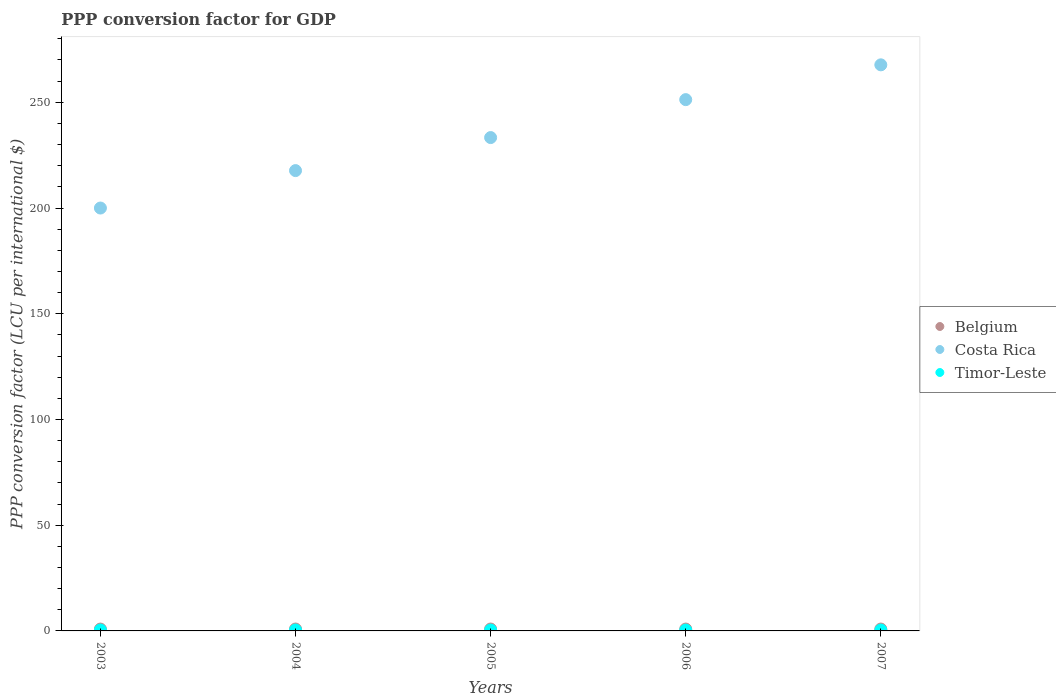How many different coloured dotlines are there?
Ensure brevity in your answer.  3. Is the number of dotlines equal to the number of legend labels?
Provide a short and direct response. Yes. What is the PPP conversion factor for GDP in Costa Rica in 2005?
Your response must be concise. 233.31. Across all years, what is the maximum PPP conversion factor for GDP in Belgium?
Offer a very short reply. 0.9. Across all years, what is the minimum PPP conversion factor for GDP in Belgium?
Keep it short and to the point. 0.88. In which year was the PPP conversion factor for GDP in Timor-Leste maximum?
Offer a terse response. 2003. In which year was the PPP conversion factor for GDP in Timor-Leste minimum?
Your response must be concise. 2006. What is the total PPP conversion factor for GDP in Costa Rica in the graph?
Your answer should be compact. 1169.97. What is the difference between the PPP conversion factor for GDP in Belgium in 2003 and that in 2007?
Offer a very short reply. -0.01. What is the difference between the PPP conversion factor for GDP in Costa Rica in 2003 and the PPP conversion factor for GDP in Timor-Leste in 2005?
Provide a succinct answer. 199.58. What is the average PPP conversion factor for GDP in Timor-Leste per year?
Your answer should be very brief. 0.41. In the year 2006, what is the difference between the PPP conversion factor for GDP in Costa Rica and PPP conversion factor for GDP in Belgium?
Ensure brevity in your answer.  250.38. In how many years, is the PPP conversion factor for GDP in Belgium greater than 50 LCU?
Provide a short and direct response. 0. What is the ratio of the PPP conversion factor for GDP in Costa Rica in 2003 to that in 2006?
Give a very brief answer. 0.8. Is the PPP conversion factor for GDP in Costa Rica in 2005 less than that in 2006?
Your answer should be compact. Yes. What is the difference between the highest and the second highest PPP conversion factor for GDP in Costa Rica?
Your answer should be very brief. 16.45. What is the difference between the highest and the lowest PPP conversion factor for GDP in Timor-Leste?
Your answer should be very brief. 0.03. Is it the case that in every year, the sum of the PPP conversion factor for GDP in Timor-Leste and PPP conversion factor for GDP in Belgium  is greater than the PPP conversion factor for GDP in Costa Rica?
Offer a terse response. No. Does the PPP conversion factor for GDP in Timor-Leste monotonically increase over the years?
Make the answer very short. No. Is the PPP conversion factor for GDP in Costa Rica strictly greater than the PPP conversion factor for GDP in Belgium over the years?
Make the answer very short. Yes. Is the PPP conversion factor for GDP in Costa Rica strictly less than the PPP conversion factor for GDP in Belgium over the years?
Keep it short and to the point. No. How many dotlines are there?
Make the answer very short. 3. How many years are there in the graph?
Your answer should be compact. 5. What is the difference between two consecutive major ticks on the Y-axis?
Make the answer very short. 50. How are the legend labels stacked?
Give a very brief answer. Vertical. What is the title of the graph?
Offer a very short reply. PPP conversion factor for GDP. Does "Guyana" appear as one of the legend labels in the graph?
Make the answer very short. No. What is the label or title of the X-axis?
Ensure brevity in your answer.  Years. What is the label or title of the Y-axis?
Provide a succinct answer. PPP conversion factor (LCU per international $). What is the PPP conversion factor (LCU per international $) of Belgium in 2003?
Offer a terse response. 0.88. What is the PPP conversion factor (LCU per international $) of Costa Rica in 2003?
Ensure brevity in your answer.  199.99. What is the PPP conversion factor (LCU per international $) of Timor-Leste in 2003?
Provide a short and direct response. 0.42. What is the PPP conversion factor (LCU per international $) of Belgium in 2004?
Provide a succinct answer. 0.9. What is the PPP conversion factor (LCU per international $) in Costa Rica in 2004?
Provide a short and direct response. 217.69. What is the PPP conversion factor (LCU per international $) of Timor-Leste in 2004?
Offer a very short reply. 0.42. What is the PPP conversion factor (LCU per international $) in Belgium in 2005?
Make the answer very short. 0.9. What is the PPP conversion factor (LCU per international $) in Costa Rica in 2005?
Make the answer very short. 233.31. What is the PPP conversion factor (LCU per international $) in Timor-Leste in 2005?
Offer a terse response. 0.41. What is the PPP conversion factor (LCU per international $) in Belgium in 2006?
Offer a very short reply. 0.88. What is the PPP conversion factor (LCU per international $) of Costa Rica in 2006?
Offer a very short reply. 251.26. What is the PPP conversion factor (LCU per international $) of Timor-Leste in 2006?
Offer a terse response. 0.39. What is the PPP conversion factor (LCU per international $) in Belgium in 2007?
Offer a very short reply. 0.89. What is the PPP conversion factor (LCU per international $) of Costa Rica in 2007?
Ensure brevity in your answer.  267.71. What is the PPP conversion factor (LCU per international $) in Timor-Leste in 2007?
Offer a very short reply. 0.42. Across all years, what is the maximum PPP conversion factor (LCU per international $) of Belgium?
Provide a short and direct response. 0.9. Across all years, what is the maximum PPP conversion factor (LCU per international $) of Costa Rica?
Keep it short and to the point. 267.71. Across all years, what is the maximum PPP conversion factor (LCU per international $) in Timor-Leste?
Ensure brevity in your answer.  0.42. Across all years, what is the minimum PPP conversion factor (LCU per international $) of Belgium?
Your answer should be very brief. 0.88. Across all years, what is the minimum PPP conversion factor (LCU per international $) in Costa Rica?
Ensure brevity in your answer.  199.99. Across all years, what is the minimum PPP conversion factor (LCU per international $) in Timor-Leste?
Your answer should be compact. 0.39. What is the total PPP conversion factor (LCU per international $) of Belgium in the graph?
Give a very brief answer. 4.44. What is the total PPP conversion factor (LCU per international $) in Costa Rica in the graph?
Provide a short and direct response. 1169.97. What is the total PPP conversion factor (LCU per international $) in Timor-Leste in the graph?
Make the answer very short. 2.07. What is the difference between the PPP conversion factor (LCU per international $) of Belgium in 2003 and that in 2004?
Make the answer very short. -0.02. What is the difference between the PPP conversion factor (LCU per international $) in Costa Rica in 2003 and that in 2004?
Your response must be concise. -17.7. What is the difference between the PPP conversion factor (LCU per international $) of Timor-Leste in 2003 and that in 2004?
Provide a succinct answer. 0. What is the difference between the PPP conversion factor (LCU per international $) of Belgium in 2003 and that in 2005?
Provide a short and direct response. -0.02. What is the difference between the PPP conversion factor (LCU per international $) in Costa Rica in 2003 and that in 2005?
Offer a very short reply. -33.32. What is the difference between the PPP conversion factor (LCU per international $) of Timor-Leste in 2003 and that in 2005?
Provide a succinct answer. 0.02. What is the difference between the PPP conversion factor (LCU per international $) in Belgium in 2003 and that in 2006?
Your answer should be compact. -0.01. What is the difference between the PPP conversion factor (LCU per international $) of Costa Rica in 2003 and that in 2006?
Ensure brevity in your answer.  -51.27. What is the difference between the PPP conversion factor (LCU per international $) in Timor-Leste in 2003 and that in 2006?
Your response must be concise. 0.03. What is the difference between the PPP conversion factor (LCU per international $) of Belgium in 2003 and that in 2007?
Ensure brevity in your answer.  -0.01. What is the difference between the PPP conversion factor (LCU per international $) of Costa Rica in 2003 and that in 2007?
Give a very brief answer. -67.72. What is the difference between the PPP conversion factor (LCU per international $) in Timor-Leste in 2003 and that in 2007?
Your answer should be compact. 0.01. What is the difference between the PPP conversion factor (LCU per international $) of Belgium in 2004 and that in 2005?
Your response must be concise. -0. What is the difference between the PPP conversion factor (LCU per international $) of Costa Rica in 2004 and that in 2005?
Offer a terse response. -15.62. What is the difference between the PPP conversion factor (LCU per international $) in Timor-Leste in 2004 and that in 2005?
Offer a terse response. 0.02. What is the difference between the PPP conversion factor (LCU per international $) of Belgium in 2004 and that in 2006?
Your answer should be very brief. 0.01. What is the difference between the PPP conversion factor (LCU per international $) of Costa Rica in 2004 and that in 2006?
Give a very brief answer. -33.56. What is the difference between the PPP conversion factor (LCU per international $) in Timor-Leste in 2004 and that in 2006?
Offer a terse response. 0.03. What is the difference between the PPP conversion factor (LCU per international $) in Belgium in 2004 and that in 2007?
Your answer should be very brief. 0.01. What is the difference between the PPP conversion factor (LCU per international $) in Costa Rica in 2004 and that in 2007?
Your answer should be compact. -50.02. What is the difference between the PPP conversion factor (LCU per international $) of Timor-Leste in 2004 and that in 2007?
Give a very brief answer. 0.01. What is the difference between the PPP conversion factor (LCU per international $) in Belgium in 2005 and that in 2006?
Keep it short and to the point. 0.02. What is the difference between the PPP conversion factor (LCU per international $) of Costa Rica in 2005 and that in 2006?
Provide a short and direct response. -17.94. What is the difference between the PPP conversion factor (LCU per international $) in Timor-Leste in 2005 and that in 2006?
Provide a short and direct response. 0.01. What is the difference between the PPP conversion factor (LCU per international $) of Belgium in 2005 and that in 2007?
Your response must be concise. 0.01. What is the difference between the PPP conversion factor (LCU per international $) of Costa Rica in 2005 and that in 2007?
Your response must be concise. -34.4. What is the difference between the PPP conversion factor (LCU per international $) in Timor-Leste in 2005 and that in 2007?
Provide a short and direct response. -0.01. What is the difference between the PPP conversion factor (LCU per international $) of Belgium in 2006 and that in 2007?
Make the answer very short. -0. What is the difference between the PPP conversion factor (LCU per international $) in Costa Rica in 2006 and that in 2007?
Keep it short and to the point. -16.45. What is the difference between the PPP conversion factor (LCU per international $) of Timor-Leste in 2006 and that in 2007?
Keep it short and to the point. -0.02. What is the difference between the PPP conversion factor (LCU per international $) of Belgium in 2003 and the PPP conversion factor (LCU per international $) of Costa Rica in 2004?
Ensure brevity in your answer.  -216.82. What is the difference between the PPP conversion factor (LCU per international $) in Belgium in 2003 and the PPP conversion factor (LCU per international $) in Timor-Leste in 2004?
Ensure brevity in your answer.  0.45. What is the difference between the PPP conversion factor (LCU per international $) of Costa Rica in 2003 and the PPP conversion factor (LCU per international $) of Timor-Leste in 2004?
Your answer should be compact. 199.57. What is the difference between the PPP conversion factor (LCU per international $) in Belgium in 2003 and the PPP conversion factor (LCU per international $) in Costa Rica in 2005?
Your answer should be very brief. -232.44. What is the difference between the PPP conversion factor (LCU per international $) in Belgium in 2003 and the PPP conversion factor (LCU per international $) in Timor-Leste in 2005?
Make the answer very short. 0.47. What is the difference between the PPP conversion factor (LCU per international $) in Costa Rica in 2003 and the PPP conversion factor (LCU per international $) in Timor-Leste in 2005?
Your response must be concise. 199.58. What is the difference between the PPP conversion factor (LCU per international $) of Belgium in 2003 and the PPP conversion factor (LCU per international $) of Costa Rica in 2006?
Your answer should be very brief. -250.38. What is the difference between the PPP conversion factor (LCU per international $) of Belgium in 2003 and the PPP conversion factor (LCU per international $) of Timor-Leste in 2006?
Offer a terse response. 0.48. What is the difference between the PPP conversion factor (LCU per international $) of Costa Rica in 2003 and the PPP conversion factor (LCU per international $) of Timor-Leste in 2006?
Provide a short and direct response. 199.6. What is the difference between the PPP conversion factor (LCU per international $) in Belgium in 2003 and the PPP conversion factor (LCU per international $) in Costa Rica in 2007?
Ensure brevity in your answer.  -266.83. What is the difference between the PPP conversion factor (LCU per international $) of Belgium in 2003 and the PPP conversion factor (LCU per international $) of Timor-Leste in 2007?
Make the answer very short. 0.46. What is the difference between the PPP conversion factor (LCU per international $) in Costa Rica in 2003 and the PPP conversion factor (LCU per international $) in Timor-Leste in 2007?
Provide a short and direct response. 199.57. What is the difference between the PPP conversion factor (LCU per international $) of Belgium in 2004 and the PPP conversion factor (LCU per international $) of Costa Rica in 2005?
Your answer should be compact. -232.42. What is the difference between the PPP conversion factor (LCU per international $) of Belgium in 2004 and the PPP conversion factor (LCU per international $) of Timor-Leste in 2005?
Keep it short and to the point. 0.49. What is the difference between the PPP conversion factor (LCU per international $) of Costa Rica in 2004 and the PPP conversion factor (LCU per international $) of Timor-Leste in 2005?
Your answer should be compact. 217.29. What is the difference between the PPP conversion factor (LCU per international $) in Belgium in 2004 and the PPP conversion factor (LCU per international $) in Costa Rica in 2006?
Ensure brevity in your answer.  -250.36. What is the difference between the PPP conversion factor (LCU per international $) of Belgium in 2004 and the PPP conversion factor (LCU per international $) of Timor-Leste in 2006?
Ensure brevity in your answer.  0.5. What is the difference between the PPP conversion factor (LCU per international $) in Costa Rica in 2004 and the PPP conversion factor (LCU per international $) in Timor-Leste in 2006?
Offer a terse response. 217.3. What is the difference between the PPP conversion factor (LCU per international $) in Belgium in 2004 and the PPP conversion factor (LCU per international $) in Costa Rica in 2007?
Ensure brevity in your answer.  -266.82. What is the difference between the PPP conversion factor (LCU per international $) of Belgium in 2004 and the PPP conversion factor (LCU per international $) of Timor-Leste in 2007?
Keep it short and to the point. 0.48. What is the difference between the PPP conversion factor (LCU per international $) in Costa Rica in 2004 and the PPP conversion factor (LCU per international $) in Timor-Leste in 2007?
Offer a terse response. 217.28. What is the difference between the PPP conversion factor (LCU per international $) in Belgium in 2005 and the PPP conversion factor (LCU per international $) in Costa Rica in 2006?
Offer a very short reply. -250.36. What is the difference between the PPP conversion factor (LCU per international $) of Belgium in 2005 and the PPP conversion factor (LCU per international $) of Timor-Leste in 2006?
Your response must be concise. 0.51. What is the difference between the PPP conversion factor (LCU per international $) of Costa Rica in 2005 and the PPP conversion factor (LCU per international $) of Timor-Leste in 2006?
Offer a very short reply. 232.92. What is the difference between the PPP conversion factor (LCU per international $) in Belgium in 2005 and the PPP conversion factor (LCU per international $) in Costa Rica in 2007?
Make the answer very short. -266.81. What is the difference between the PPP conversion factor (LCU per international $) in Belgium in 2005 and the PPP conversion factor (LCU per international $) in Timor-Leste in 2007?
Your answer should be compact. 0.48. What is the difference between the PPP conversion factor (LCU per international $) of Costa Rica in 2005 and the PPP conversion factor (LCU per international $) of Timor-Leste in 2007?
Make the answer very short. 232.9. What is the difference between the PPP conversion factor (LCU per international $) of Belgium in 2006 and the PPP conversion factor (LCU per international $) of Costa Rica in 2007?
Your answer should be very brief. -266.83. What is the difference between the PPP conversion factor (LCU per international $) of Belgium in 2006 and the PPP conversion factor (LCU per international $) of Timor-Leste in 2007?
Provide a short and direct response. 0.47. What is the difference between the PPP conversion factor (LCU per international $) of Costa Rica in 2006 and the PPP conversion factor (LCU per international $) of Timor-Leste in 2007?
Provide a succinct answer. 250.84. What is the average PPP conversion factor (LCU per international $) in Belgium per year?
Ensure brevity in your answer.  0.89. What is the average PPP conversion factor (LCU per international $) in Costa Rica per year?
Provide a succinct answer. 233.99. What is the average PPP conversion factor (LCU per international $) in Timor-Leste per year?
Provide a succinct answer. 0.41. In the year 2003, what is the difference between the PPP conversion factor (LCU per international $) of Belgium and PPP conversion factor (LCU per international $) of Costa Rica?
Offer a terse response. -199.11. In the year 2003, what is the difference between the PPP conversion factor (LCU per international $) in Belgium and PPP conversion factor (LCU per international $) in Timor-Leste?
Your answer should be very brief. 0.45. In the year 2003, what is the difference between the PPP conversion factor (LCU per international $) in Costa Rica and PPP conversion factor (LCU per international $) in Timor-Leste?
Keep it short and to the point. 199.57. In the year 2004, what is the difference between the PPP conversion factor (LCU per international $) of Belgium and PPP conversion factor (LCU per international $) of Costa Rica?
Offer a terse response. -216.8. In the year 2004, what is the difference between the PPP conversion factor (LCU per international $) in Belgium and PPP conversion factor (LCU per international $) in Timor-Leste?
Your answer should be compact. 0.47. In the year 2004, what is the difference between the PPP conversion factor (LCU per international $) of Costa Rica and PPP conversion factor (LCU per international $) of Timor-Leste?
Make the answer very short. 217.27. In the year 2005, what is the difference between the PPP conversion factor (LCU per international $) of Belgium and PPP conversion factor (LCU per international $) of Costa Rica?
Provide a short and direct response. -232.41. In the year 2005, what is the difference between the PPP conversion factor (LCU per international $) in Belgium and PPP conversion factor (LCU per international $) in Timor-Leste?
Provide a succinct answer. 0.49. In the year 2005, what is the difference between the PPP conversion factor (LCU per international $) of Costa Rica and PPP conversion factor (LCU per international $) of Timor-Leste?
Your answer should be compact. 232.91. In the year 2006, what is the difference between the PPP conversion factor (LCU per international $) of Belgium and PPP conversion factor (LCU per international $) of Costa Rica?
Offer a terse response. -250.38. In the year 2006, what is the difference between the PPP conversion factor (LCU per international $) of Belgium and PPP conversion factor (LCU per international $) of Timor-Leste?
Offer a terse response. 0.49. In the year 2006, what is the difference between the PPP conversion factor (LCU per international $) of Costa Rica and PPP conversion factor (LCU per international $) of Timor-Leste?
Your answer should be compact. 250.86. In the year 2007, what is the difference between the PPP conversion factor (LCU per international $) of Belgium and PPP conversion factor (LCU per international $) of Costa Rica?
Make the answer very short. -266.83. In the year 2007, what is the difference between the PPP conversion factor (LCU per international $) of Belgium and PPP conversion factor (LCU per international $) of Timor-Leste?
Provide a succinct answer. 0.47. In the year 2007, what is the difference between the PPP conversion factor (LCU per international $) in Costa Rica and PPP conversion factor (LCU per international $) in Timor-Leste?
Provide a short and direct response. 267.3. What is the ratio of the PPP conversion factor (LCU per international $) in Belgium in 2003 to that in 2004?
Your response must be concise. 0.98. What is the ratio of the PPP conversion factor (LCU per international $) in Costa Rica in 2003 to that in 2004?
Offer a very short reply. 0.92. What is the ratio of the PPP conversion factor (LCU per international $) in Timor-Leste in 2003 to that in 2004?
Give a very brief answer. 1. What is the ratio of the PPP conversion factor (LCU per international $) of Belgium in 2003 to that in 2005?
Your answer should be very brief. 0.98. What is the ratio of the PPP conversion factor (LCU per international $) in Costa Rica in 2003 to that in 2005?
Offer a very short reply. 0.86. What is the ratio of the PPP conversion factor (LCU per international $) of Timor-Leste in 2003 to that in 2005?
Keep it short and to the point. 1.04. What is the ratio of the PPP conversion factor (LCU per international $) in Costa Rica in 2003 to that in 2006?
Provide a succinct answer. 0.8. What is the ratio of the PPP conversion factor (LCU per international $) of Timor-Leste in 2003 to that in 2006?
Give a very brief answer. 1.08. What is the ratio of the PPP conversion factor (LCU per international $) of Belgium in 2003 to that in 2007?
Provide a succinct answer. 0.99. What is the ratio of the PPP conversion factor (LCU per international $) of Costa Rica in 2003 to that in 2007?
Give a very brief answer. 0.75. What is the ratio of the PPP conversion factor (LCU per international $) in Timor-Leste in 2003 to that in 2007?
Make the answer very short. 1.02. What is the ratio of the PPP conversion factor (LCU per international $) in Belgium in 2004 to that in 2005?
Your answer should be compact. 1. What is the ratio of the PPP conversion factor (LCU per international $) of Costa Rica in 2004 to that in 2005?
Offer a terse response. 0.93. What is the ratio of the PPP conversion factor (LCU per international $) in Timor-Leste in 2004 to that in 2005?
Keep it short and to the point. 1.04. What is the ratio of the PPP conversion factor (LCU per international $) in Belgium in 2004 to that in 2006?
Your response must be concise. 1.02. What is the ratio of the PPP conversion factor (LCU per international $) of Costa Rica in 2004 to that in 2006?
Ensure brevity in your answer.  0.87. What is the ratio of the PPP conversion factor (LCU per international $) of Timor-Leste in 2004 to that in 2006?
Make the answer very short. 1.07. What is the ratio of the PPP conversion factor (LCU per international $) of Belgium in 2004 to that in 2007?
Your answer should be compact. 1.01. What is the ratio of the PPP conversion factor (LCU per international $) of Costa Rica in 2004 to that in 2007?
Provide a short and direct response. 0.81. What is the ratio of the PPP conversion factor (LCU per international $) in Timor-Leste in 2004 to that in 2007?
Give a very brief answer. 1.02. What is the ratio of the PPP conversion factor (LCU per international $) of Belgium in 2005 to that in 2006?
Give a very brief answer. 1.02. What is the ratio of the PPP conversion factor (LCU per international $) of Timor-Leste in 2005 to that in 2006?
Make the answer very short. 1.03. What is the ratio of the PPP conversion factor (LCU per international $) of Belgium in 2005 to that in 2007?
Make the answer very short. 1.01. What is the ratio of the PPP conversion factor (LCU per international $) of Costa Rica in 2005 to that in 2007?
Provide a succinct answer. 0.87. What is the ratio of the PPP conversion factor (LCU per international $) in Timor-Leste in 2005 to that in 2007?
Provide a succinct answer. 0.98. What is the ratio of the PPP conversion factor (LCU per international $) of Costa Rica in 2006 to that in 2007?
Provide a succinct answer. 0.94. What is the ratio of the PPP conversion factor (LCU per international $) in Timor-Leste in 2006 to that in 2007?
Provide a succinct answer. 0.95. What is the difference between the highest and the second highest PPP conversion factor (LCU per international $) of Belgium?
Give a very brief answer. 0. What is the difference between the highest and the second highest PPP conversion factor (LCU per international $) in Costa Rica?
Your answer should be very brief. 16.45. What is the difference between the highest and the second highest PPP conversion factor (LCU per international $) in Timor-Leste?
Make the answer very short. 0. What is the difference between the highest and the lowest PPP conversion factor (LCU per international $) in Belgium?
Your answer should be compact. 0.02. What is the difference between the highest and the lowest PPP conversion factor (LCU per international $) in Costa Rica?
Your answer should be very brief. 67.72. What is the difference between the highest and the lowest PPP conversion factor (LCU per international $) in Timor-Leste?
Your response must be concise. 0.03. 